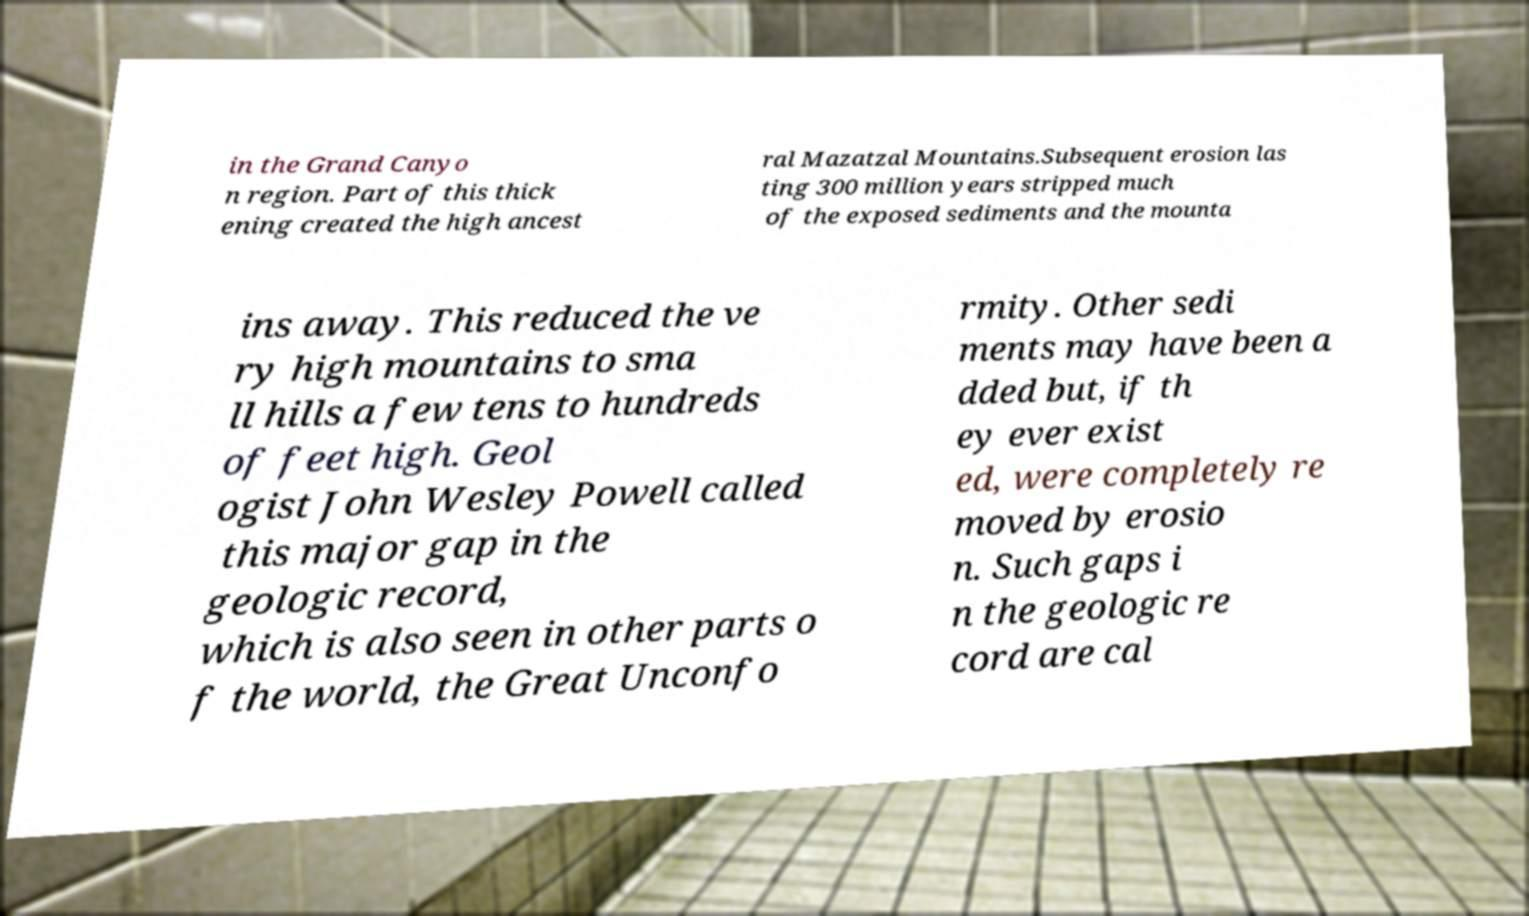I need the written content from this picture converted into text. Can you do that? in the Grand Canyo n region. Part of this thick ening created the high ancest ral Mazatzal Mountains.Subsequent erosion las ting 300 million years stripped much of the exposed sediments and the mounta ins away. This reduced the ve ry high mountains to sma ll hills a few tens to hundreds of feet high. Geol ogist John Wesley Powell called this major gap in the geologic record, which is also seen in other parts o f the world, the Great Unconfo rmity. Other sedi ments may have been a dded but, if th ey ever exist ed, were completely re moved by erosio n. Such gaps i n the geologic re cord are cal 